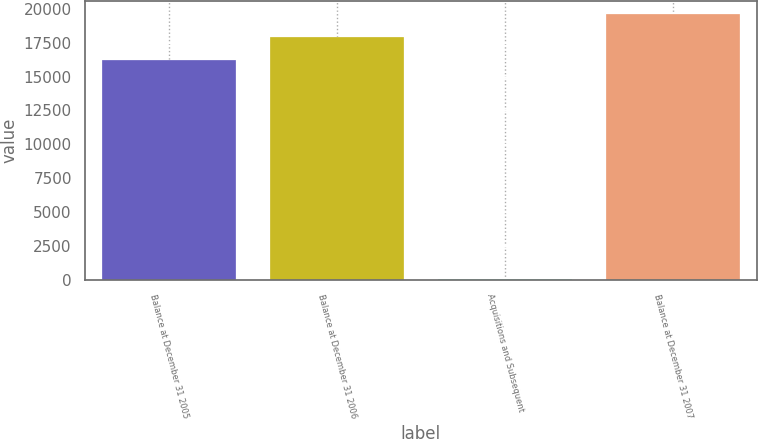Convert chart. <chart><loc_0><loc_0><loc_500><loc_500><bar_chart><fcel>Balance at December 31 2005<fcel>Balance at December 31 2006<fcel>Acquisitions and Subsequent<fcel>Balance at December 31 2007<nl><fcel>16238<fcel>17920.2<fcel>32<fcel>19602.4<nl></chart> 